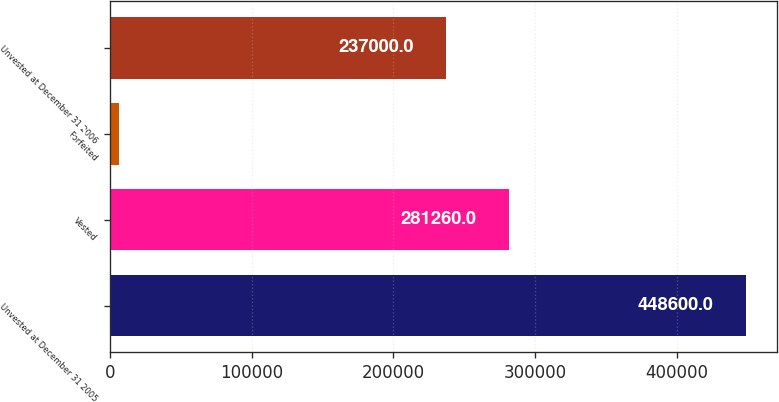Convert chart. <chart><loc_0><loc_0><loc_500><loc_500><bar_chart><fcel>Unvested at December 31 2005<fcel>Vested<fcel>Forfeited<fcel>Unvested at December 31 2006<nl><fcel>448600<fcel>281260<fcel>6000<fcel>237000<nl></chart> 